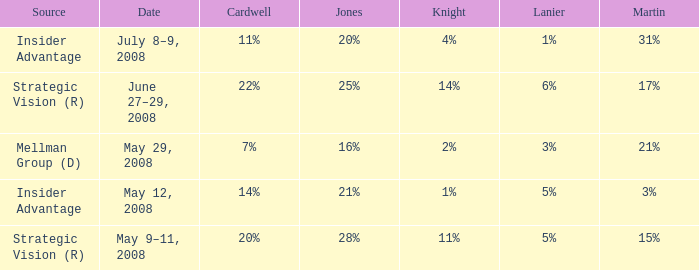What source has a Knight of 2%? Mellman Group (D). Give me the full table as a dictionary. {'header': ['Source', 'Date', 'Cardwell', 'Jones', 'Knight', 'Lanier', 'Martin'], 'rows': [['Insider Advantage', 'July 8–9, 2008', '11%', '20%', '4%', '1%', '31%'], ['Strategic Vision (R)', 'June 27–29, 2008', '22%', '25%', '14%', '6%', '17%'], ['Mellman Group (D)', 'May 29, 2008', '7%', '16%', '2%', '3%', '21%'], ['Insider Advantage', 'May 12, 2008', '14%', '21%', '1%', '5%', '3%'], ['Strategic Vision (R)', 'May 9–11, 2008', '20%', '28%', '11%', '5%', '15%']]} 